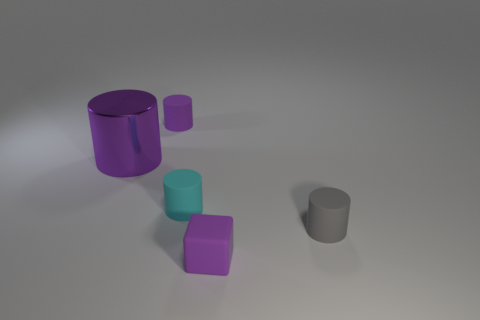Subtract all purple cylinders. How many were subtracted if there are1purple cylinders left? 1 Subtract 1 cylinders. How many cylinders are left? 3 Add 1 small cyan rubber things. How many objects exist? 6 Subtract all cylinders. How many objects are left? 1 Subtract 1 cyan cylinders. How many objects are left? 4 Subtract all large purple things. Subtract all cylinders. How many objects are left? 0 Add 3 small gray rubber objects. How many small gray rubber objects are left? 4 Add 2 purple matte objects. How many purple matte objects exist? 4 